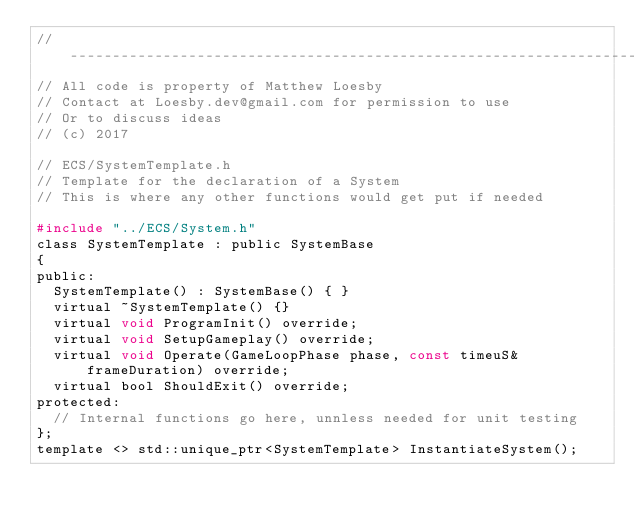Convert code to text. <code><loc_0><loc_0><loc_500><loc_500><_C_>//-----------------------------------------------------------------------------
// All code is property of Matthew Loesby
// Contact at Loesby.dev@gmail.com for permission to use
// Or to discuss ideas
// (c) 2017

// ECS/SystemTemplate.h
// Template for the declaration of a System
// This is where any other functions would get put if needed

#include "../ECS/System.h"
class SystemTemplate : public SystemBase
{
public:
	SystemTemplate() : SystemBase() { }
	virtual ~SystemTemplate() {}
	virtual void ProgramInit() override;
	virtual void SetupGameplay() override;
	virtual void Operate(GameLoopPhase phase, const timeuS& frameDuration) override;
	virtual bool ShouldExit() override;
protected:
	// Internal functions go here, unnless needed for unit testing
};
template <> std::unique_ptr<SystemTemplate> InstantiateSystem();</code> 